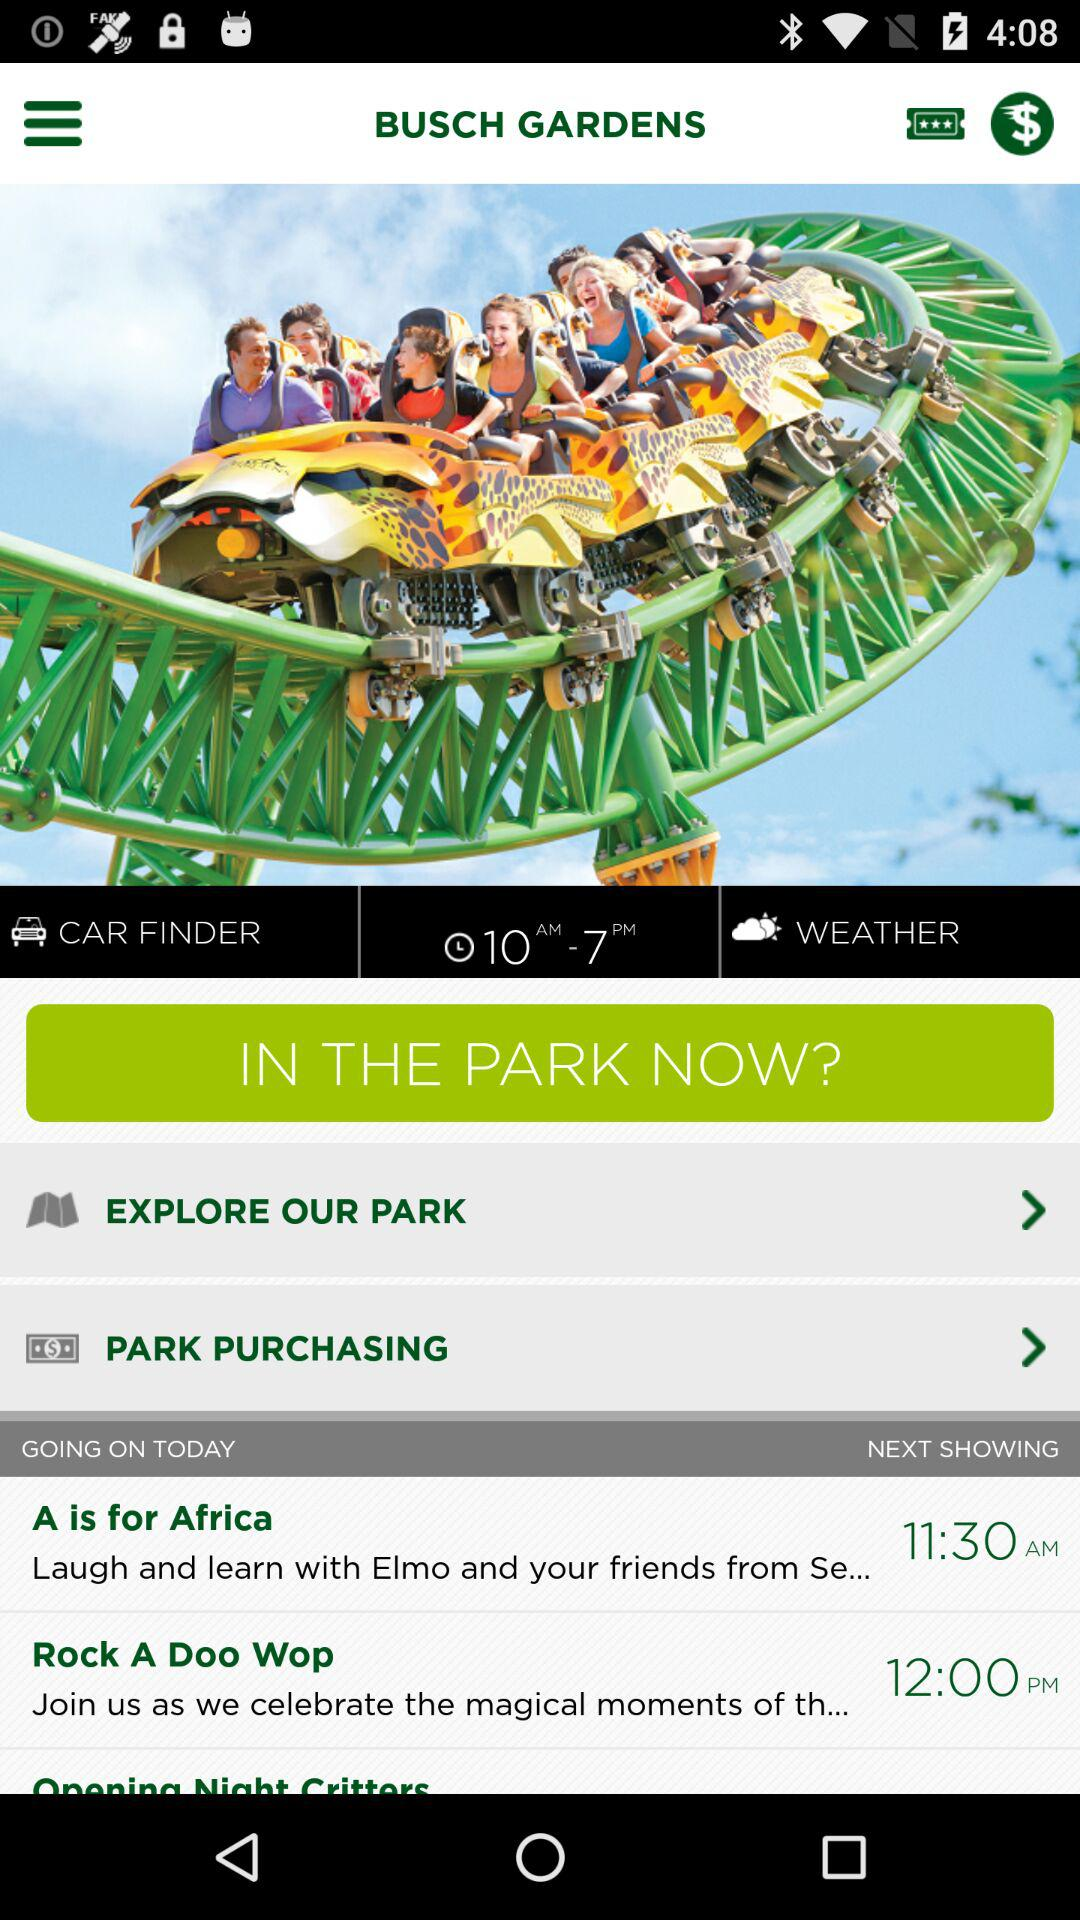When is the next showing of "Opening Night Critters"?
When the provided information is insufficient, respond with <no answer>. <no answer> 